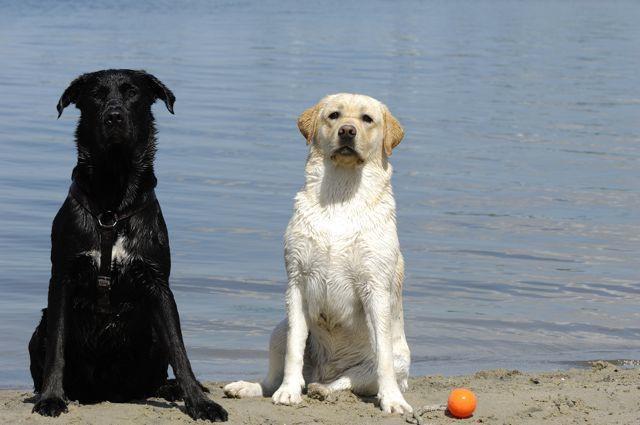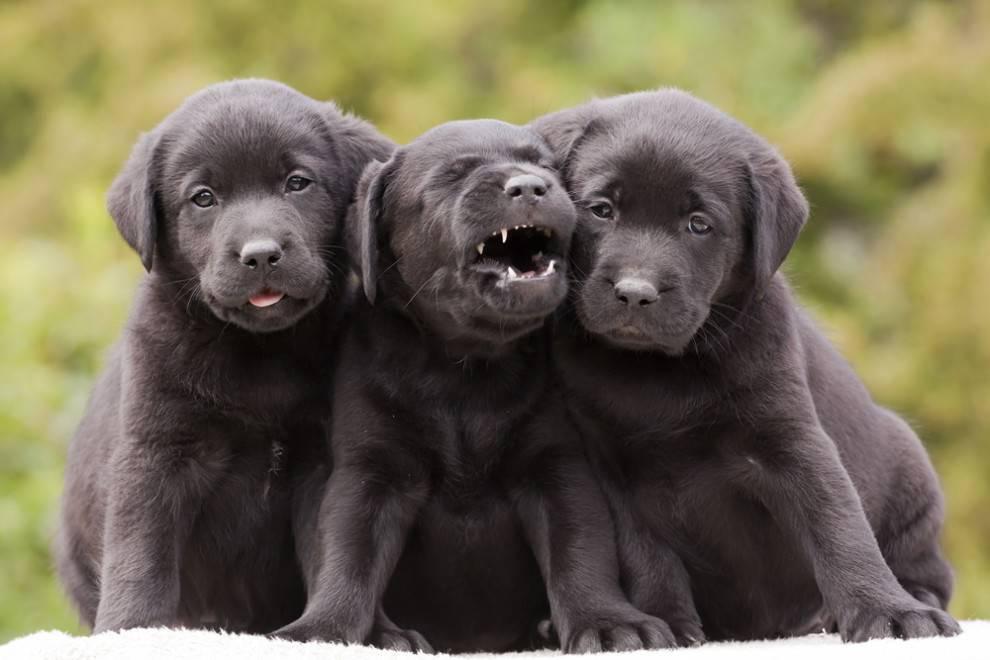The first image is the image on the left, the second image is the image on the right. For the images shown, is this caption "One image shows exactly two adult dogs, and the other image shows a row of at least three puppies sitting upright." true? Answer yes or no. Yes. The first image is the image on the left, the second image is the image on the right. Examine the images to the left and right. Is the description "There are more dogs in the image on the left." accurate? Answer yes or no. No. 